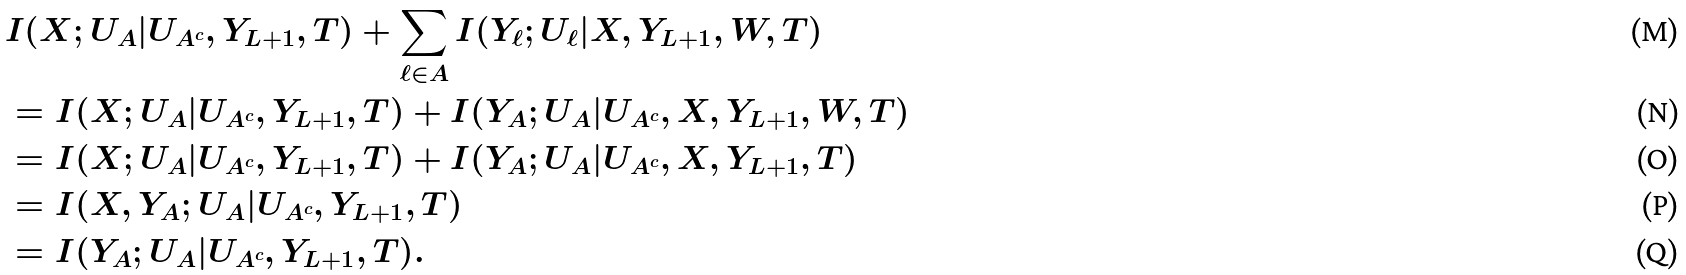Convert formula to latex. <formula><loc_0><loc_0><loc_500><loc_500>& I ( X ; U _ { A } | U _ { A ^ { c } } , Y _ { L + 1 } , T ) + \sum _ { \ell \in A } I ( Y _ { \ell } ; U _ { \ell } | X , Y _ { L + 1 } , W , T ) \\ & = I ( X ; U _ { A } | U _ { A ^ { c } } , Y _ { L + 1 } , T ) + I ( Y _ { A } ; U _ { A } | U _ { A ^ { c } } , X , Y _ { L + 1 } , W , T ) \\ & = I ( X ; U _ { A } | U _ { A ^ { c } } , Y _ { L + 1 } , T ) + I ( Y _ { A } ; U _ { A } | U _ { A ^ { c } } , X , Y _ { L + 1 } , T ) \\ & = I ( X , Y _ { A } ; U _ { A } | U _ { A ^ { c } } , Y _ { L + 1 } , T ) \\ & = I ( Y _ { A } ; U _ { A } | U _ { A ^ { c } } , Y _ { L + 1 } , T ) .</formula> 